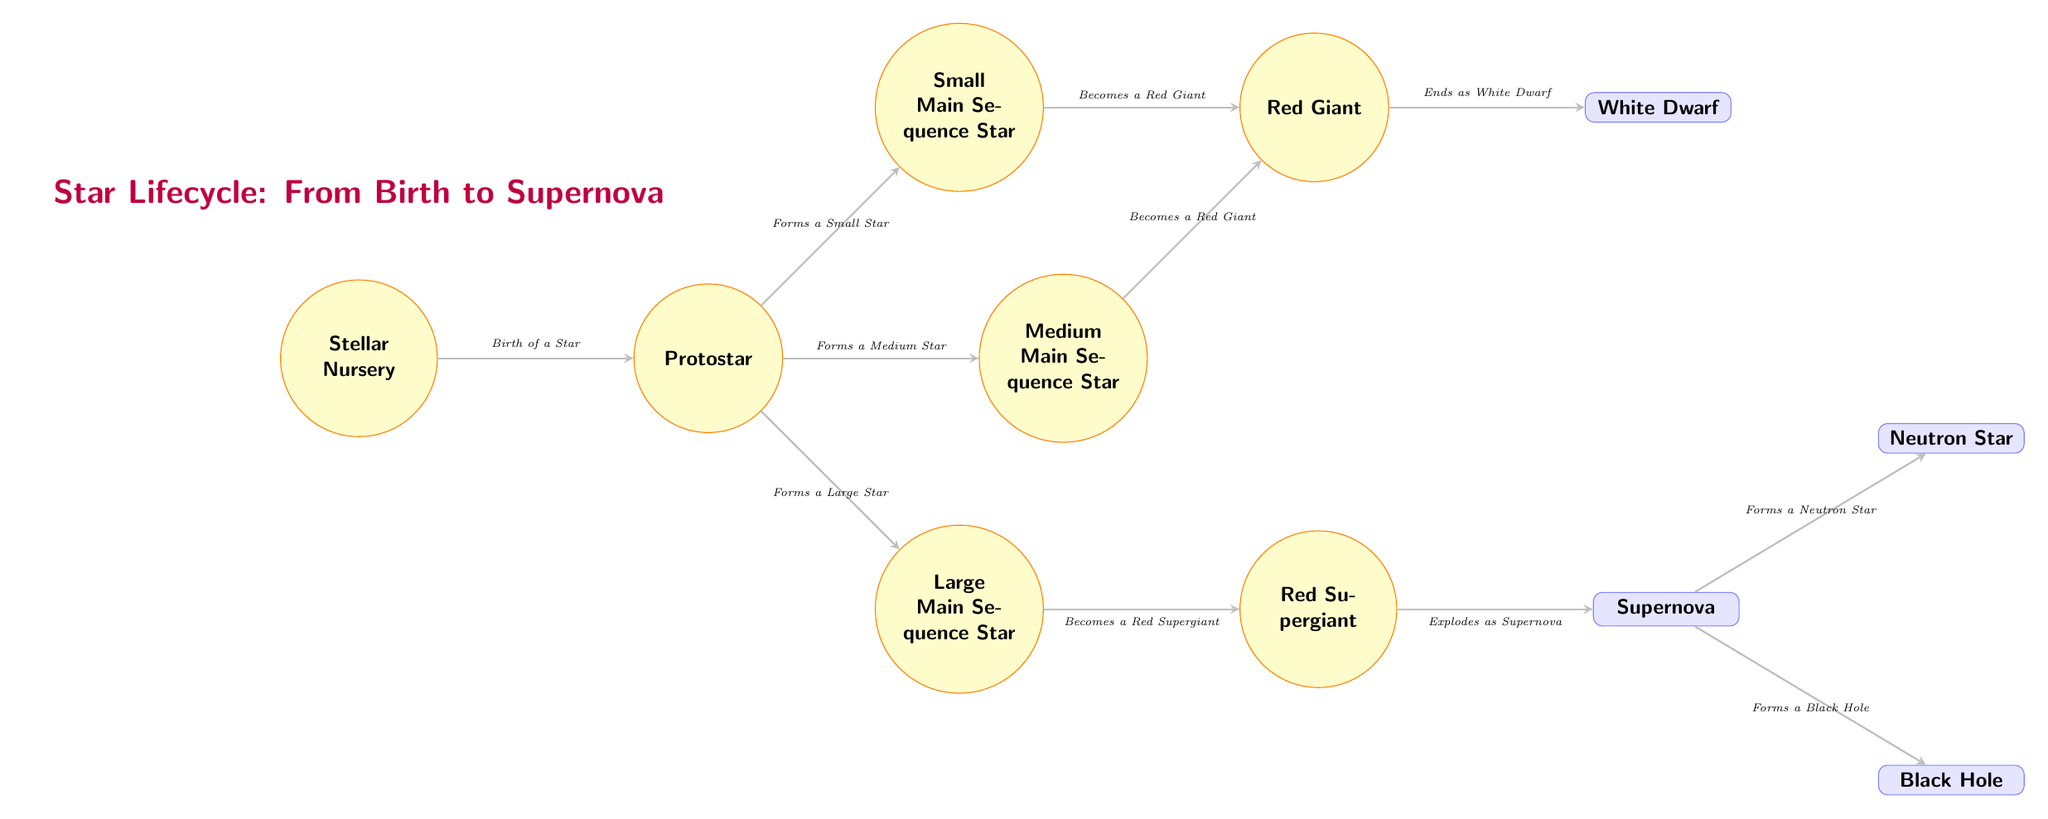What is the first stage in the star lifecycle? The diagram shows that the first stage in the star lifecycle is the "Stellar Nursery," which is where the birth of a star occurs.
Answer: Stellar Nursery Which type of star does a protostar primarily form into? According to the diagram, a protostar can transform into a small, medium, or large main sequence star, but specifically smaller or medium stars are indicated more directly as the next stages.
Answer: Small Main Sequence Star What follows after a small main sequence star? The diagram indicates that after a small main sequence star, the next stage is "Red Giant." This is a subsequent evolutionary phase for small stars.
Answer: Red Giant How does a large main sequence star end its lifecycle? The diagram states that a large main sequence star evolves into a "Red Supergiant," and ultimately ends its lifecycle by exploding as a "Supernova," leading to either a neutron star or a black hole, as shown in its pathway.
Answer: Explodes as Supernova What are the two potential ends for a large star after a supernova? Post-supernova, the diagram delineates that the two possible endpoints for a large star are either a "Neutron Star" or a "Black Hole," depending on the remaining mass.
Answer: Neutron Star or Black Hole How many types of stars are formed from the protostar? Analyzing the diagram shows that a protostar can lead to three branching types of stars: a small, medium, and large main sequence star. Thus, there are three types.
Answer: Three types At what stage does a small or medium star transition to a later stage? The diagram specifies that both small and medium main sequence stars evolve into a "Red Giant," indicating this is their transitional stage before reaching their endings.
Answer: Red Giant Which stage is depicted after the "Red Supergiant"? The diagram represents the immediate following stage after "Red Supergiant" as "Supernova," highlighting its explosive end.
Answer: Supernova 